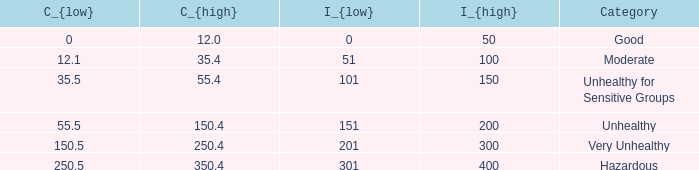What's the c_{low} value when c_{high} is equal to 1 0.0. 